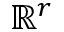Convert formula to latex. <formula><loc_0><loc_0><loc_500><loc_500>\mathbb { R } ^ { r }</formula> 